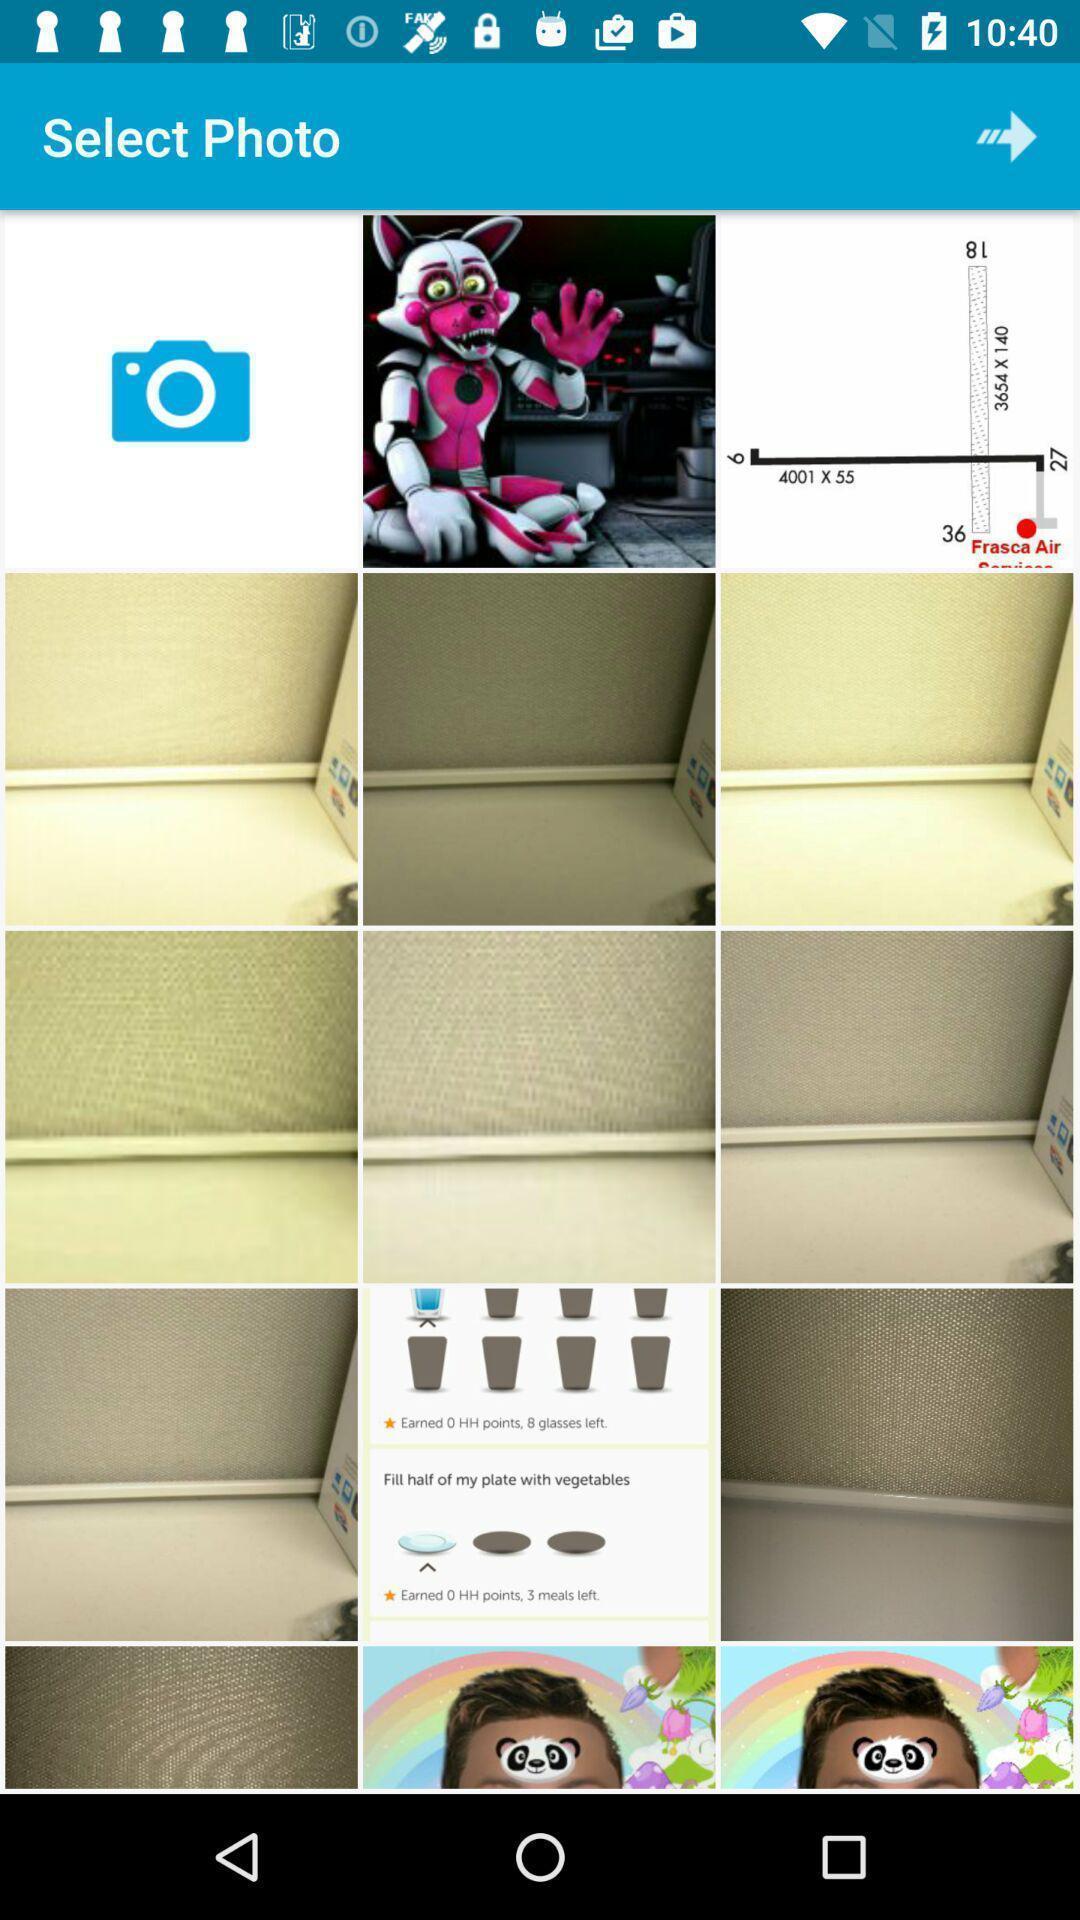Explain the elements present in this screenshot. Screen shows multiple images in app. 